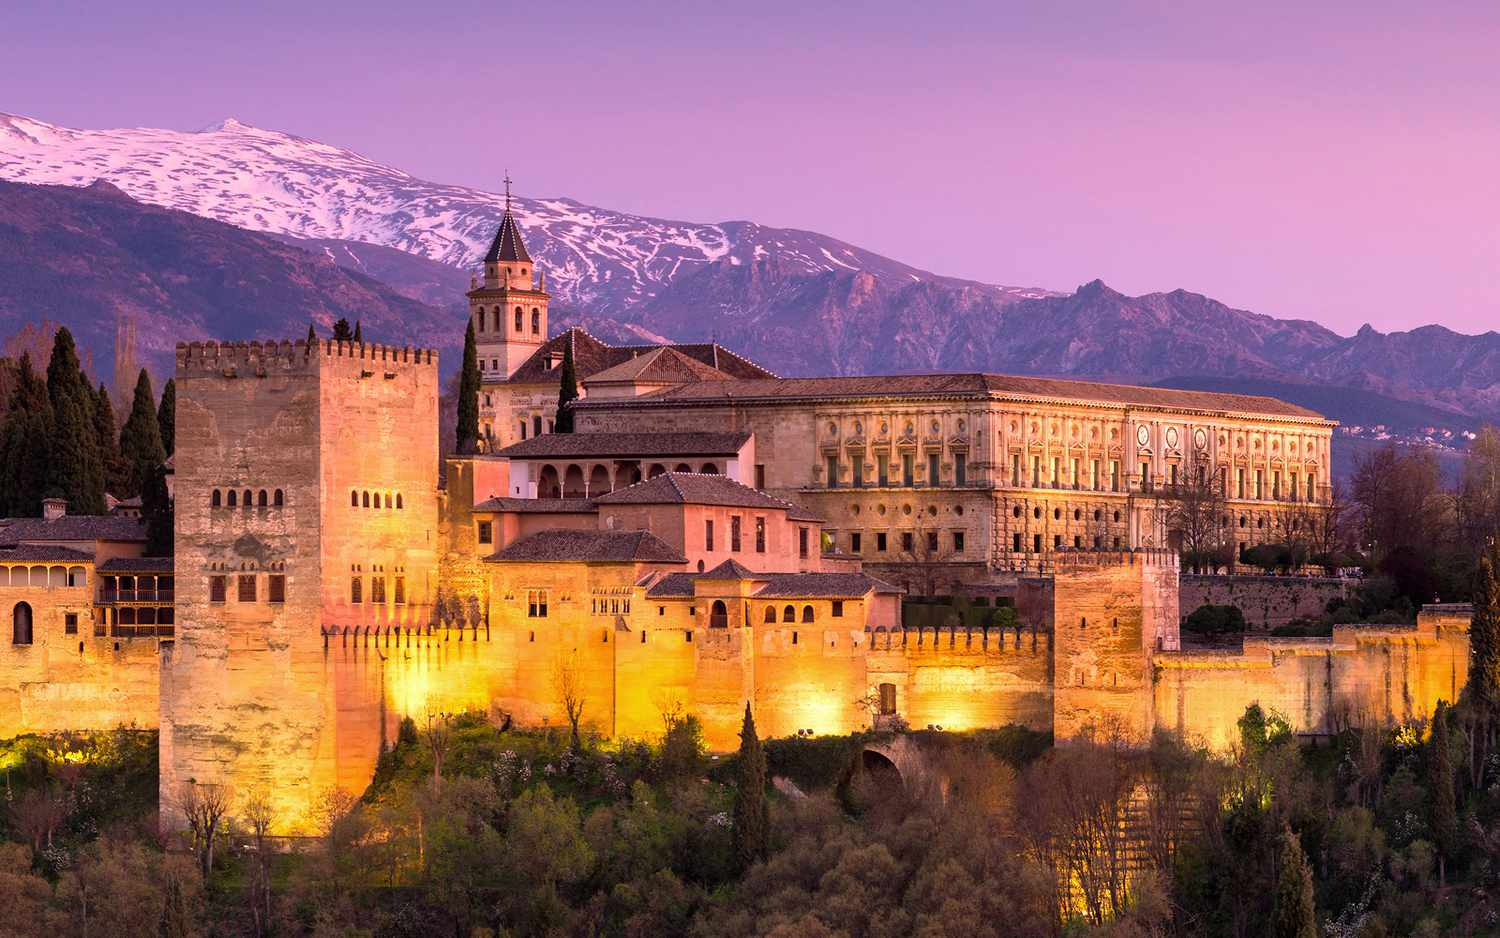Can you tell me more about the history of the Alhambra? The Alhambra's history is as multifaceted as its architecture. Constructed on the remains of Roman fortifications, it was originally built as a small fortress in AD 889. It was later rebuilt in the mid-13th century by the Nasrid Emir Mohammed ben Al-Ahmar and transformed into a palatial complex. Under the rule of Yusuf I and Muhammad V, the Alhambra was beautified with the torre de Comares, the Patio de los Leones, and other significant additions. Marking the end of Muslim rule in Spain, it was the site where Ferdinand and Isabella received Christopher Columbus. The Alhambra stands today as a testament to Islamic architecture and is a UNESCO World Heritage Site. 